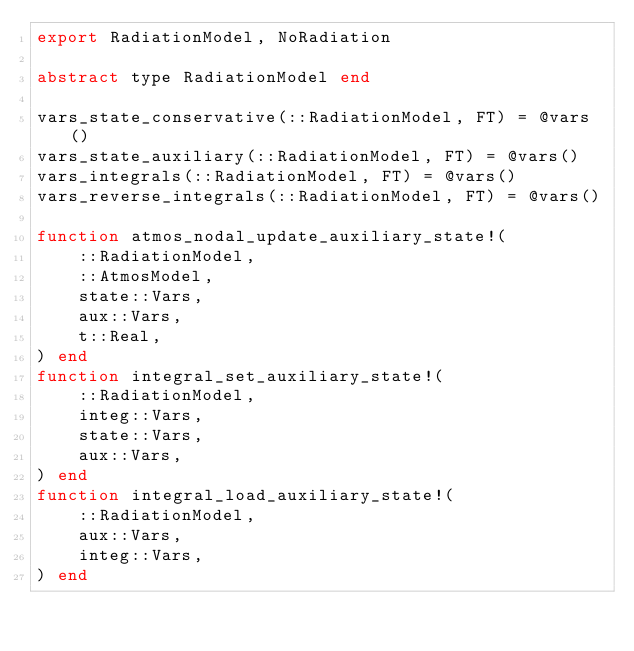Convert code to text. <code><loc_0><loc_0><loc_500><loc_500><_Julia_>export RadiationModel, NoRadiation

abstract type RadiationModel end

vars_state_conservative(::RadiationModel, FT) = @vars()
vars_state_auxiliary(::RadiationModel, FT) = @vars()
vars_integrals(::RadiationModel, FT) = @vars()
vars_reverse_integrals(::RadiationModel, FT) = @vars()

function atmos_nodal_update_auxiliary_state!(
    ::RadiationModel,
    ::AtmosModel,
    state::Vars,
    aux::Vars,
    t::Real,
) end
function integral_set_auxiliary_state!(
    ::RadiationModel,
    integ::Vars,
    state::Vars,
    aux::Vars,
) end
function integral_load_auxiliary_state!(
    ::RadiationModel,
    aux::Vars,
    integ::Vars,
) end</code> 